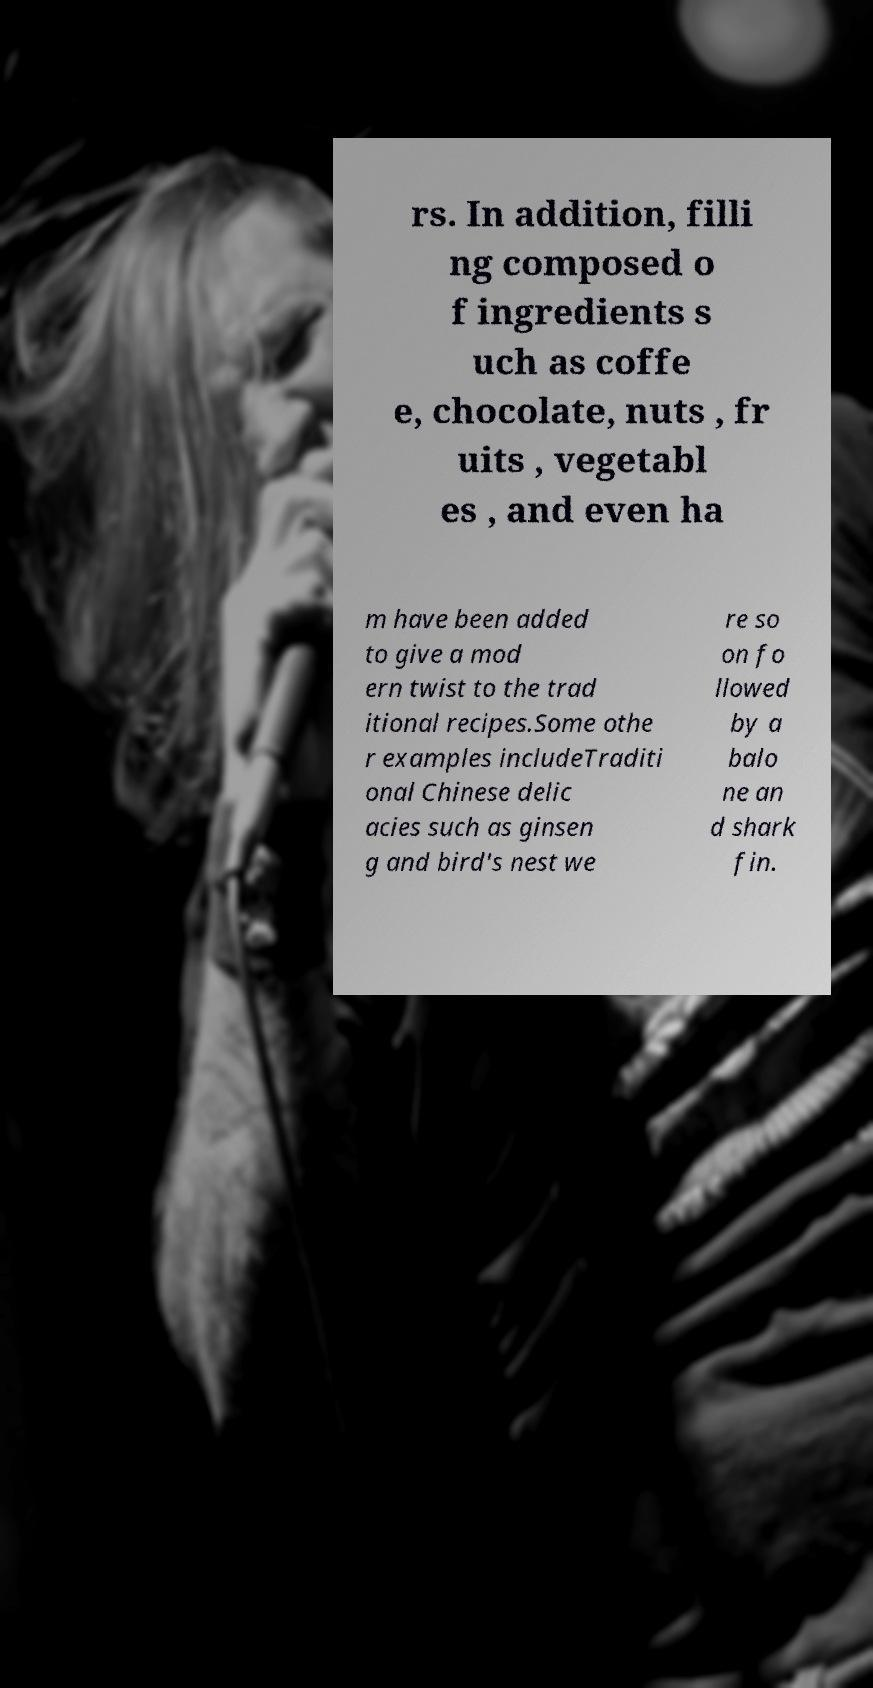There's text embedded in this image that I need extracted. Can you transcribe it verbatim? rs. In addition, filli ng composed o f ingredients s uch as coffe e, chocolate, nuts , fr uits , vegetabl es , and even ha m have been added to give a mod ern twist to the trad itional recipes.Some othe r examples includeTraditi onal Chinese delic acies such as ginsen g and bird's nest we re so on fo llowed by a balo ne an d shark fin. 